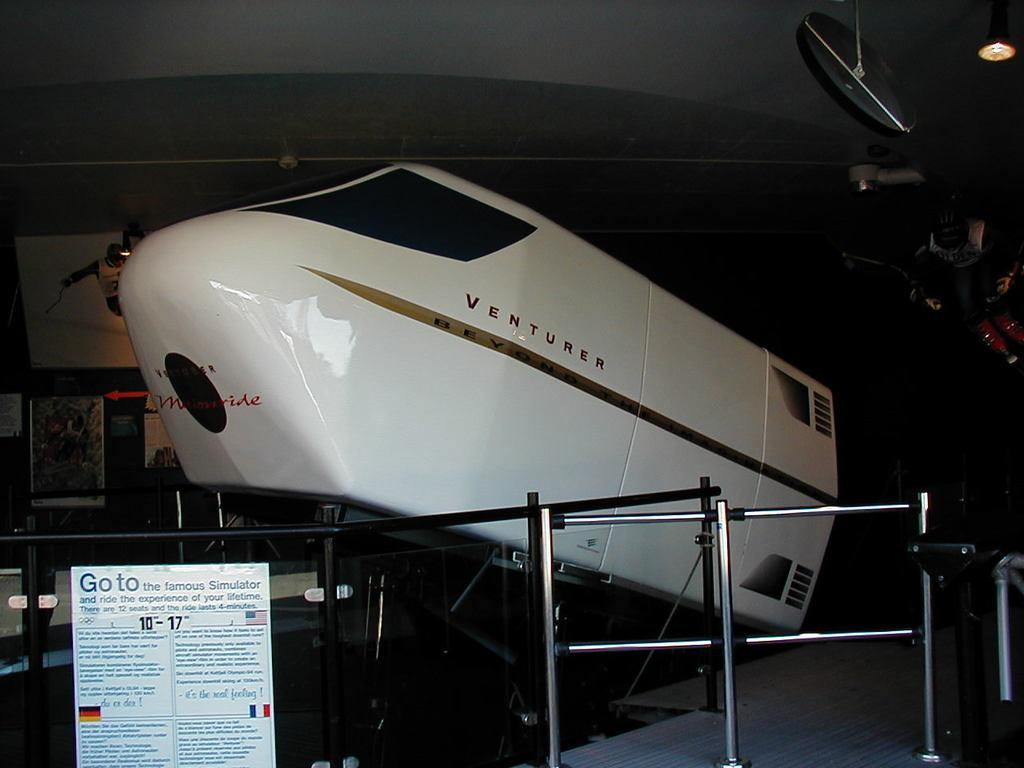<image>
Present a compact description of the photo's key features. A simulator called Venturer has a sign in front with information. 